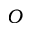<formula> <loc_0><loc_0><loc_500><loc_500>O</formula> 